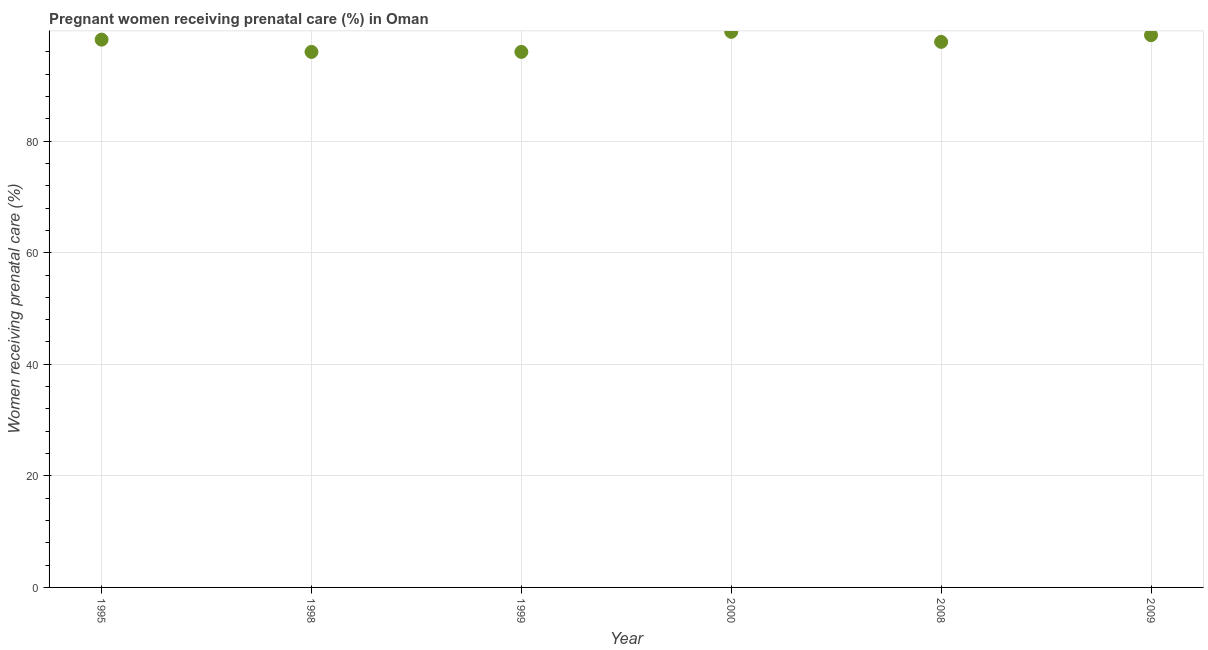What is the percentage of pregnant women receiving prenatal care in 2008?
Your answer should be very brief. 97.8. Across all years, what is the maximum percentage of pregnant women receiving prenatal care?
Your answer should be very brief. 99.6. Across all years, what is the minimum percentage of pregnant women receiving prenatal care?
Provide a succinct answer. 96. In which year was the percentage of pregnant women receiving prenatal care maximum?
Offer a terse response. 2000. In which year was the percentage of pregnant women receiving prenatal care minimum?
Keep it short and to the point. 1998. What is the sum of the percentage of pregnant women receiving prenatal care?
Offer a very short reply. 586.6. What is the difference between the percentage of pregnant women receiving prenatal care in 1998 and 2008?
Give a very brief answer. -1.8. What is the average percentage of pregnant women receiving prenatal care per year?
Make the answer very short. 97.77. What is the median percentage of pregnant women receiving prenatal care?
Offer a very short reply. 98. In how many years, is the percentage of pregnant women receiving prenatal care greater than 88 %?
Provide a short and direct response. 6. What is the ratio of the percentage of pregnant women receiving prenatal care in 2008 to that in 2009?
Offer a very short reply. 0.99. Is the percentage of pregnant women receiving prenatal care in 2008 less than that in 2009?
Your response must be concise. Yes. What is the difference between the highest and the second highest percentage of pregnant women receiving prenatal care?
Offer a very short reply. 0.6. Is the sum of the percentage of pregnant women receiving prenatal care in 1998 and 2000 greater than the maximum percentage of pregnant women receiving prenatal care across all years?
Provide a succinct answer. Yes. What is the difference between the highest and the lowest percentage of pregnant women receiving prenatal care?
Your response must be concise. 3.6. Does the percentage of pregnant women receiving prenatal care monotonically increase over the years?
Your answer should be compact. No. How many years are there in the graph?
Your answer should be compact. 6. Does the graph contain grids?
Your response must be concise. Yes. What is the title of the graph?
Your answer should be very brief. Pregnant women receiving prenatal care (%) in Oman. What is the label or title of the Y-axis?
Offer a terse response. Women receiving prenatal care (%). What is the Women receiving prenatal care (%) in 1995?
Ensure brevity in your answer.  98.2. What is the Women receiving prenatal care (%) in 1998?
Your response must be concise. 96. What is the Women receiving prenatal care (%) in 1999?
Your answer should be very brief. 96. What is the Women receiving prenatal care (%) in 2000?
Give a very brief answer. 99.6. What is the Women receiving prenatal care (%) in 2008?
Offer a very short reply. 97.8. What is the difference between the Women receiving prenatal care (%) in 1995 and 1998?
Make the answer very short. 2.2. What is the difference between the Women receiving prenatal care (%) in 1995 and 1999?
Your answer should be very brief. 2.2. What is the difference between the Women receiving prenatal care (%) in 1995 and 2008?
Your response must be concise. 0.4. What is the difference between the Women receiving prenatal care (%) in 1995 and 2009?
Provide a short and direct response. -0.8. What is the difference between the Women receiving prenatal care (%) in 1998 and 2000?
Provide a succinct answer. -3.6. What is the difference between the Women receiving prenatal care (%) in 1998 and 2009?
Your answer should be compact. -3. What is the difference between the Women receiving prenatal care (%) in 1999 and 2008?
Offer a terse response. -1.8. What is the difference between the Women receiving prenatal care (%) in 2008 and 2009?
Offer a terse response. -1.2. What is the ratio of the Women receiving prenatal care (%) in 1995 to that in 1998?
Your answer should be compact. 1.02. What is the ratio of the Women receiving prenatal care (%) in 1995 to that in 1999?
Provide a succinct answer. 1.02. What is the ratio of the Women receiving prenatal care (%) in 1995 to that in 2008?
Keep it short and to the point. 1. What is the ratio of the Women receiving prenatal care (%) in 1995 to that in 2009?
Give a very brief answer. 0.99. What is the ratio of the Women receiving prenatal care (%) in 1998 to that in 1999?
Offer a very short reply. 1. What is the ratio of the Women receiving prenatal care (%) in 1998 to that in 2008?
Keep it short and to the point. 0.98. What is the ratio of the Women receiving prenatal care (%) in 2000 to that in 2009?
Make the answer very short. 1.01. 